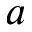<formula> <loc_0><loc_0><loc_500><loc_500>a</formula> 